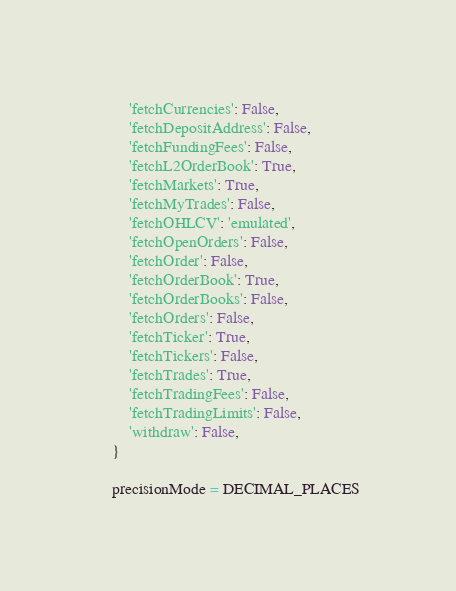<code> <loc_0><loc_0><loc_500><loc_500><_Python_>        'fetchCurrencies': False,
        'fetchDepositAddress': False,
        'fetchFundingFees': False,
        'fetchL2OrderBook': True,
        'fetchMarkets': True,
        'fetchMyTrades': False,
        'fetchOHLCV': 'emulated',
        'fetchOpenOrders': False,
        'fetchOrder': False,
        'fetchOrderBook': True,
        'fetchOrderBooks': False,
        'fetchOrders': False,
        'fetchTicker': True,
        'fetchTickers': False,
        'fetchTrades': True,
        'fetchTradingFees': False,
        'fetchTradingLimits': False,
        'withdraw': False,
    }

    precisionMode = DECIMAL_PLACES</code> 